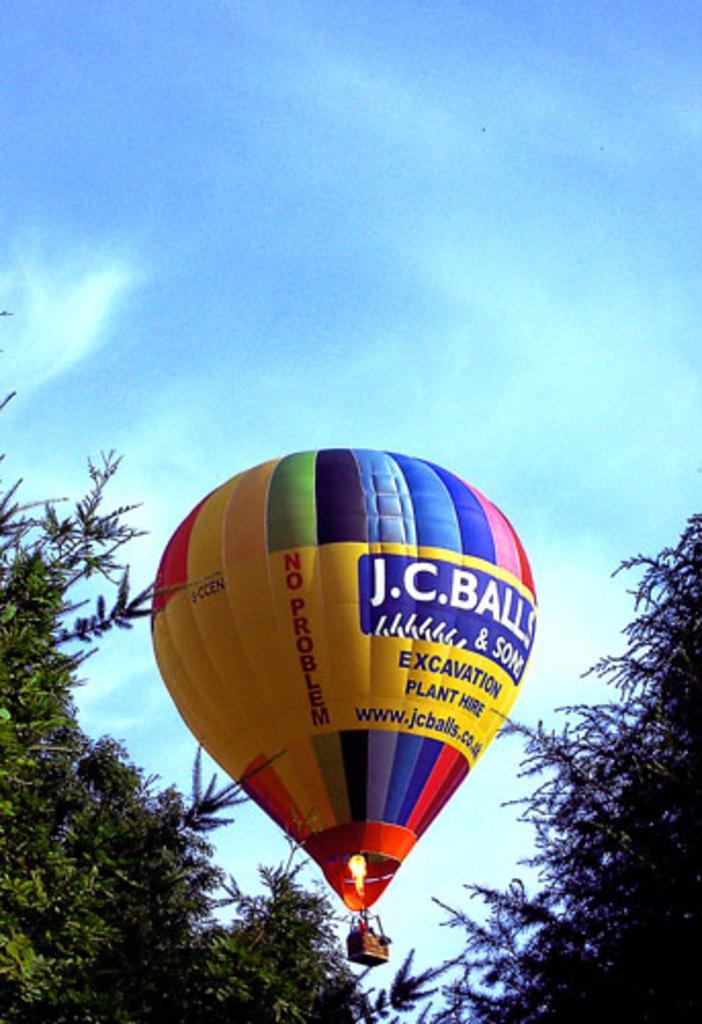Can you describe this image briefly? In this image we can see one hot air balloon, some people in the balloon basket, some fire, some text on the balloon, one object in the balloon basket, some trees on the ground and there is the sky in the background. 